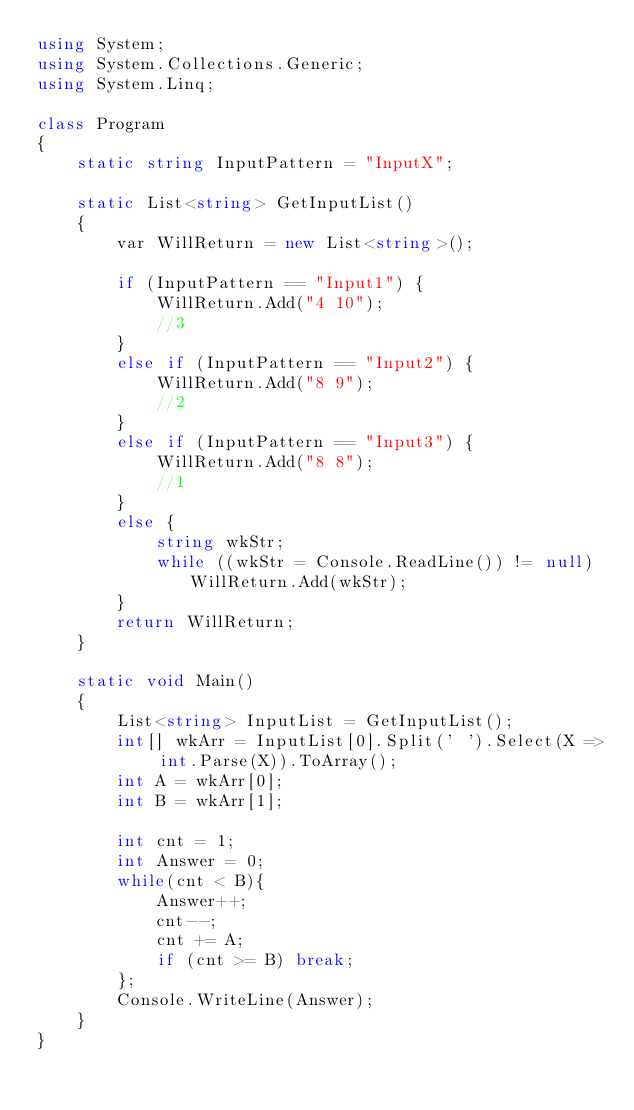Convert code to text. <code><loc_0><loc_0><loc_500><loc_500><_C#_>using System;
using System.Collections.Generic;
using System.Linq;

class Program
{
    static string InputPattern = "InputX";

    static List<string> GetInputList()
    {
        var WillReturn = new List<string>();

        if (InputPattern == "Input1") {
            WillReturn.Add("4 10");
            //3
        }
        else if (InputPattern == "Input2") {
            WillReturn.Add("8 9");
            //2
        }
        else if (InputPattern == "Input3") {
            WillReturn.Add("8 8");
            //1
        }
        else {
            string wkStr;
            while ((wkStr = Console.ReadLine()) != null) WillReturn.Add(wkStr);
        }
        return WillReturn;
    }

    static void Main()
    {
        List<string> InputList = GetInputList();
        int[] wkArr = InputList[0].Split(' ').Select(X => int.Parse(X)).ToArray();
        int A = wkArr[0];
        int B = wkArr[1];

        int cnt = 1;
        int Answer = 0;
        while(cnt < B){
            Answer++;
            cnt--;
            cnt += A;
            if (cnt >= B) break;
        };
        Console.WriteLine(Answer);
    }
}
</code> 